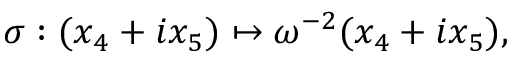<formula> <loc_0><loc_0><loc_500><loc_500>\sigma \colon ( x _ { 4 } + i x _ { 5 } ) \mapsto \omega ^ { - 2 } ( x _ { 4 } + i x _ { 5 } ) ,</formula> 